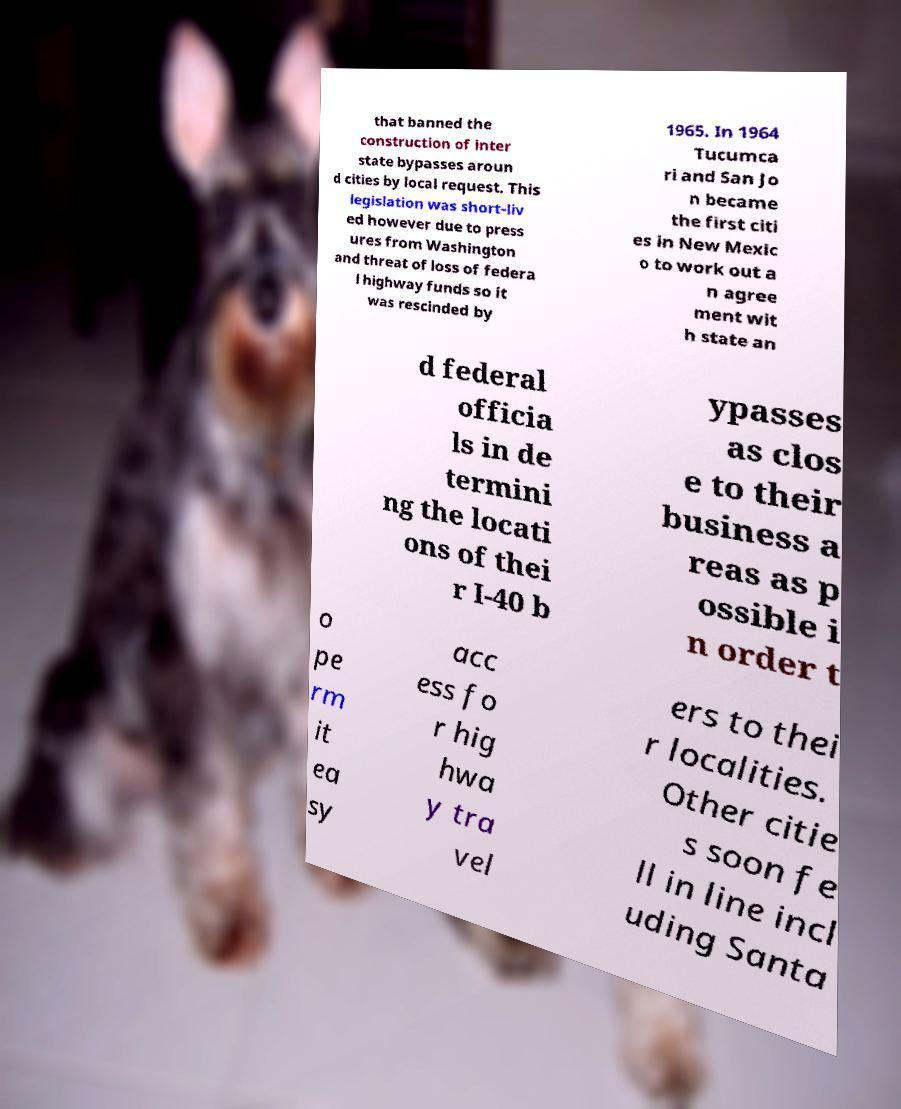Please identify and transcribe the text found in this image. that banned the construction of inter state bypasses aroun d cities by local request. This legislation was short-liv ed however due to press ures from Washington and threat of loss of federa l highway funds so it was rescinded by 1965. In 1964 Tucumca ri and San Jo n became the first citi es in New Mexic o to work out a n agree ment wit h state an d federal officia ls in de termini ng the locati ons of thei r I-40 b ypasses as clos e to their business a reas as p ossible i n order t o pe rm it ea sy acc ess fo r hig hwa y tra vel ers to thei r localities. Other citie s soon fe ll in line incl uding Santa 